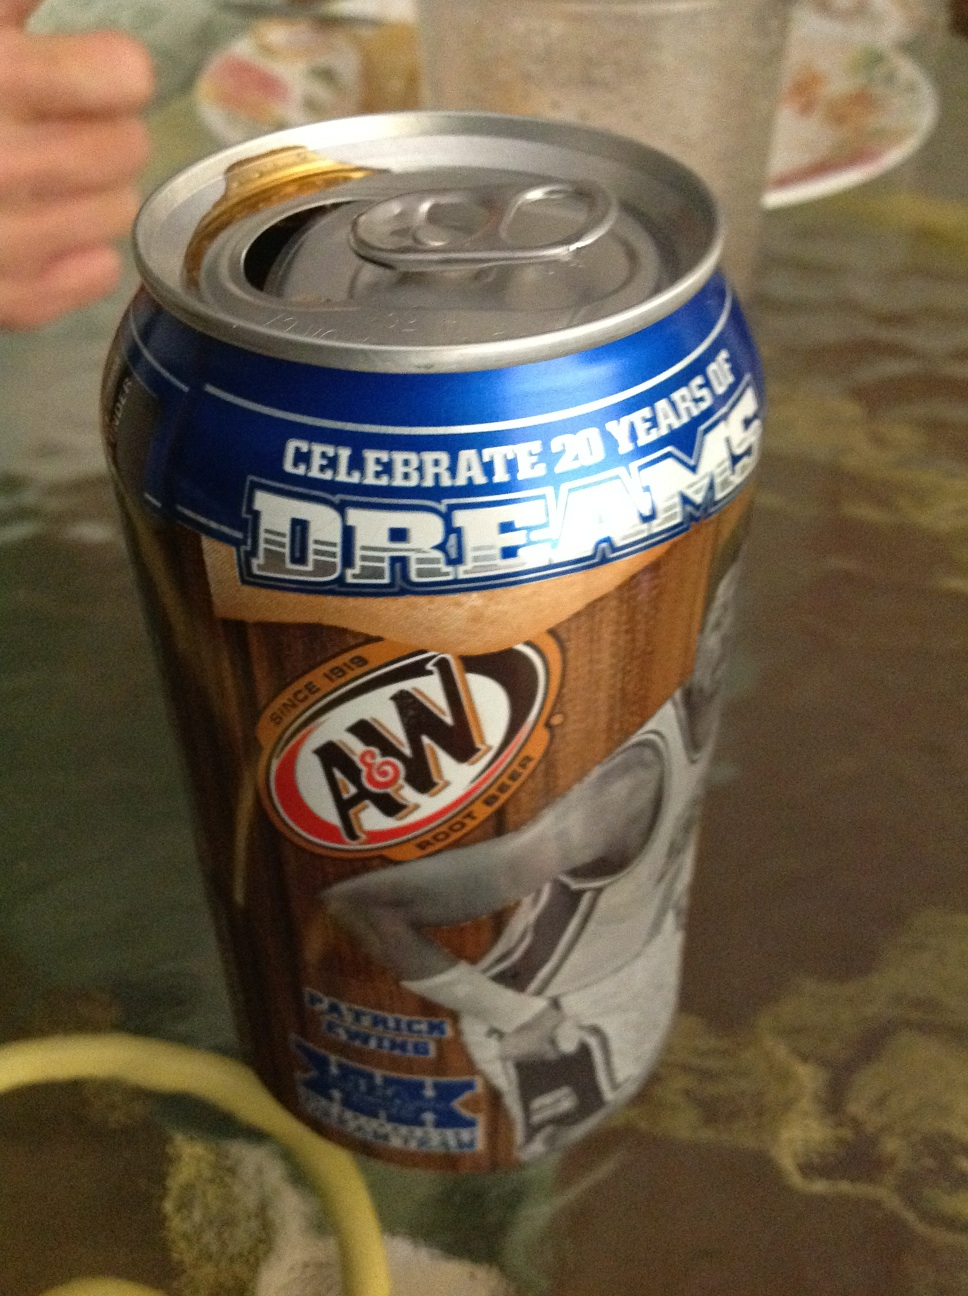What stories could this can tell if it had a voice? If this can had a voice, it would tell stories of celebrations and sporting events where joy and camaraderie bloomed. It would recount the cheers of fans in stadiums, the thrill of buzzer-beater shots, and the legacy of players like Patrick Ewing. This can could also share anecdotes about being part of family picnics, friendly gatherings, and nostalgic moments over root beer floats. 